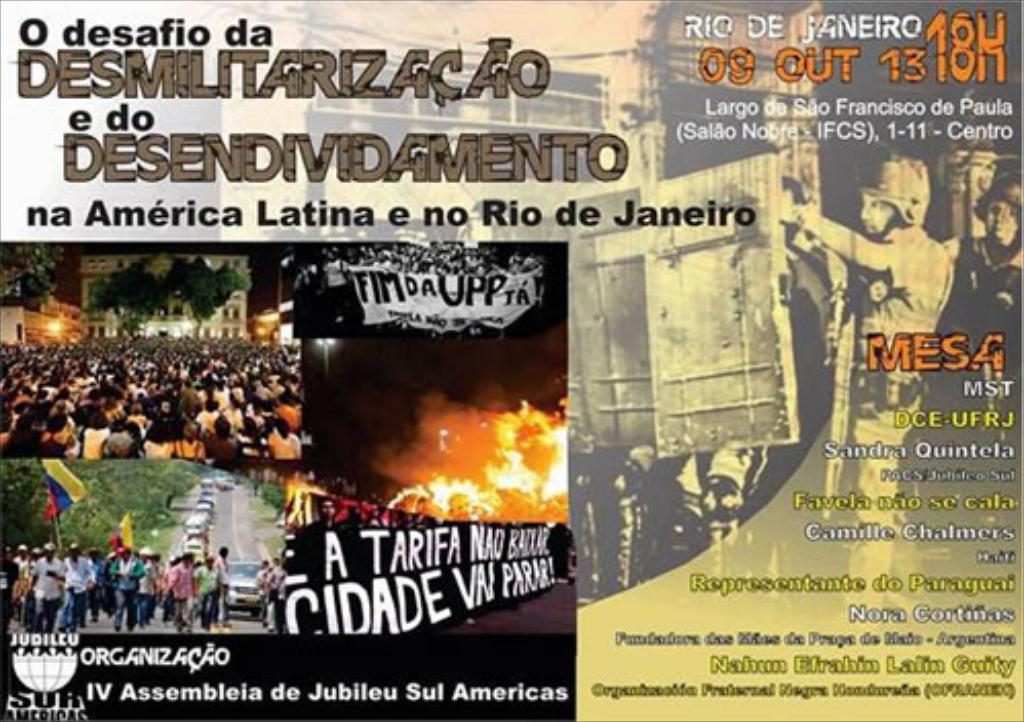Who are the likely organizers or participants mentioned on the poster? The poster references organizations and individuals such as MST (Landless Workers' Movement), DCE-UFRJ (Students' Union at the Federal University of Rio de Janeiro), and Sandra Quintela, a notable figure in social activism. These suggest involvement from grassroots movements, student groups, and local leaders. 